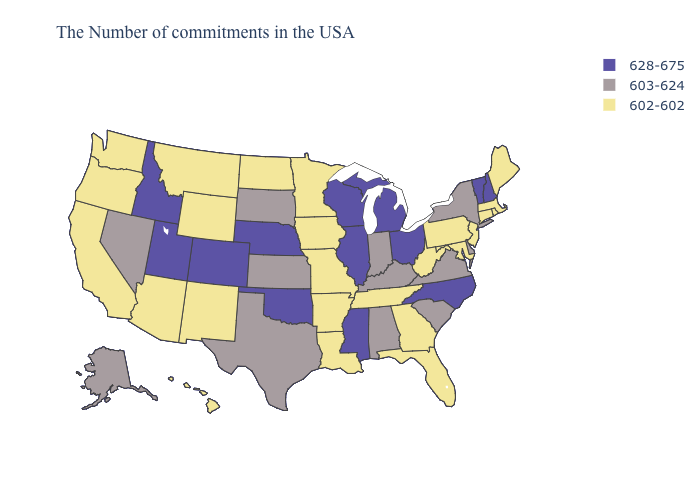What is the value of Florida?
Answer briefly. 602-602. What is the value of Utah?
Concise answer only. 628-675. Does Missouri have the lowest value in the MidWest?
Keep it brief. Yes. Name the states that have a value in the range 602-602?
Answer briefly. Maine, Massachusetts, Rhode Island, Connecticut, New Jersey, Maryland, Pennsylvania, West Virginia, Florida, Georgia, Tennessee, Louisiana, Missouri, Arkansas, Minnesota, Iowa, North Dakota, Wyoming, New Mexico, Montana, Arizona, California, Washington, Oregon, Hawaii. What is the value of Washington?
Give a very brief answer. 602-602. Name the states that have a value in the range 602-602?
Give a very brief answer. Maine, Massachusetts, Rhode Island, Connecticut, New Jersey, Maryland, Pennsylvania, West Virginia, Florida, Georgia, Tennessee, Louisiana, Missouri, Arkansas, Minnesota, Iowa, North Dakota, Wyoming, New Mexico, Montana, Arizona, California, Washington, Oregon, Hawaii. What is the highest value in states that border Pennsylvania?
Answer briefly. 628-675. Name the states that have a value in the range 628-675?
Keep it brief. New Hampshire, Vermont, North Carolina, Ohio, Michigan, Wisconsin, Illinois, Mississippi, Nebraska, Oklahoma, Colorado, Utah, Idaho. What is the value of Texas?
Write a very short answer. 603-624. What is the highest value in the USA?
Keep it brief. 628-675. Name the states that have a value in the range 602-602?
Short answer required. Maine, Massachusetts, Rhode Island, Connecticut, New Jersey, Maryland, Pennsylvania, West Virginia, Florida, Georgia, Tennessee, Louisiana, Missouri, Arkansas, Minnesota, Iowa, North Dakota, Wyoming, New Mexico, Montana, Arizona, California, Washington, Oregon, Hawaii. Among the states that border Arkansas , does Missouri have the highest value?
Short answer required. No. What is the value of New Jersey?
Be succinct. 602-602. What is the highest value in the MidWest ?
Quick response, please. 628-675. Name the states that have a value in the range 603-624?
Give a very brief answer. New York, Delaware, Virginia, South Carolina, Kentucky, Indiana, Alabama, Kansas, Texas, South Dakota, Nevada, Alaska. 